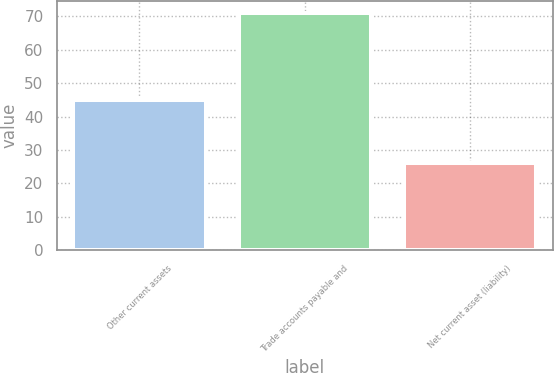Convert chart. <chart><loc_0><loc_0><loc_500><loc_500><bar_chart><fcel>Other current assets<fcel>Trade accounts payable and<fcel>Net current asset (liability)<nl><fcel>45<fcel>71<fcel>26<nl></chart> 